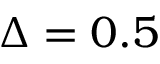Convert formula to latex. <formula><loc_0><loc_0><loc_500><loc_500>\Delta = 0 . 5</formula> 